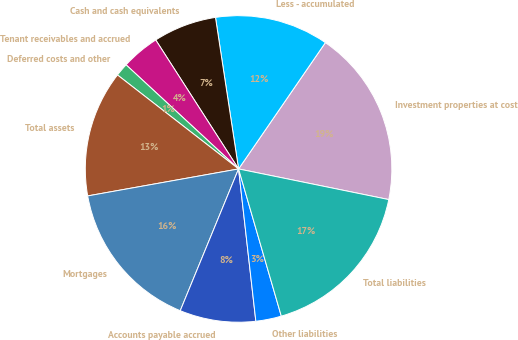Convert chart to OTSL. <chart><loc_0><loc_0><loc_500><loc_500><pie_chart><fcel>Investment properties at cost<fcel>Less - accumulated<fcel>Cash and cash equivalents<fcel>Tenant receivables and accrued<fcel>Deferred costs and other<fcel>Total assets<fcel>Mortgages<fcel>Accounts payable accrued<fcel>Other liabilities<fcel>Total liabilities<nl><fcel>18.62%<fcel>11.99%<fcel>6.68%<fcel>4.03%<fcel>1.38%<fcel>13.32%<fcel>15.97%<fcel>8.01%<fcel>2.7%<fcel>17.3%<nl></chart> 